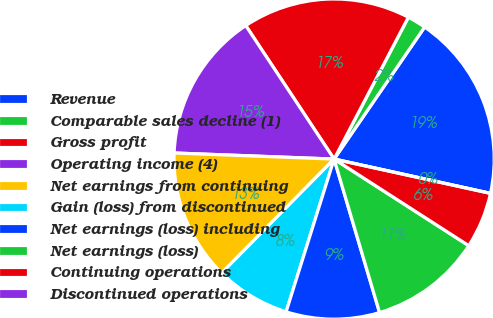Convert chart to OTSL. <chart><loc_0><loc_0><loc_500><loc_500><pie_chart><fcel>Revenue<fcel>Comparable sales decline (1)<fcel>Gross profit<fcel>Operating income (4)<fcel>Net earnings from continuing<fcel>Gain (loss) from discontinued<fcel>Net earnings (loss) including<fcel>Net earnings (loss)<fcel>Continuing operations<fcel>Discontinued operations<nl><fcel>18.87%<fcel>1.89%<fcel>16.98%<fcel>15.09%<fcel>13.21%<fcel>7.55%<fcel>9.43%<fcel>11.32%<fcel>5.66%<fcel>0.0%<nl></chart> 